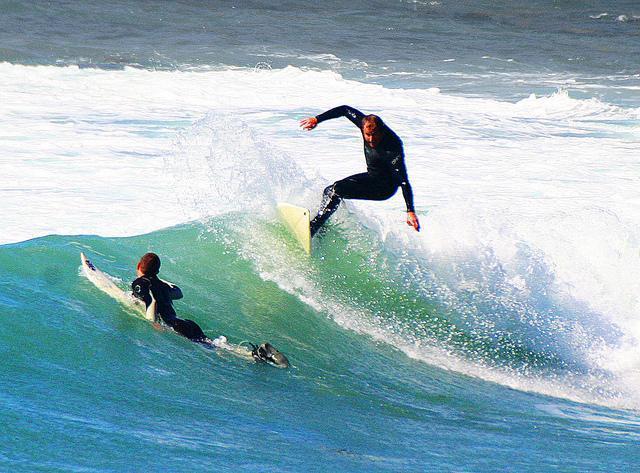How many surfers are standing?
Give a very brief answer. 1. How many people are there?
Give a very brief answer. 2. 